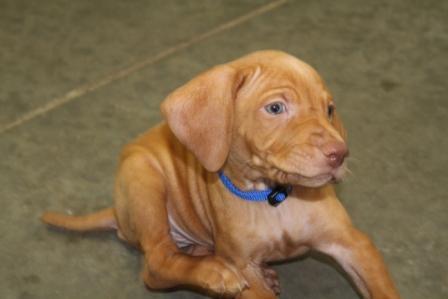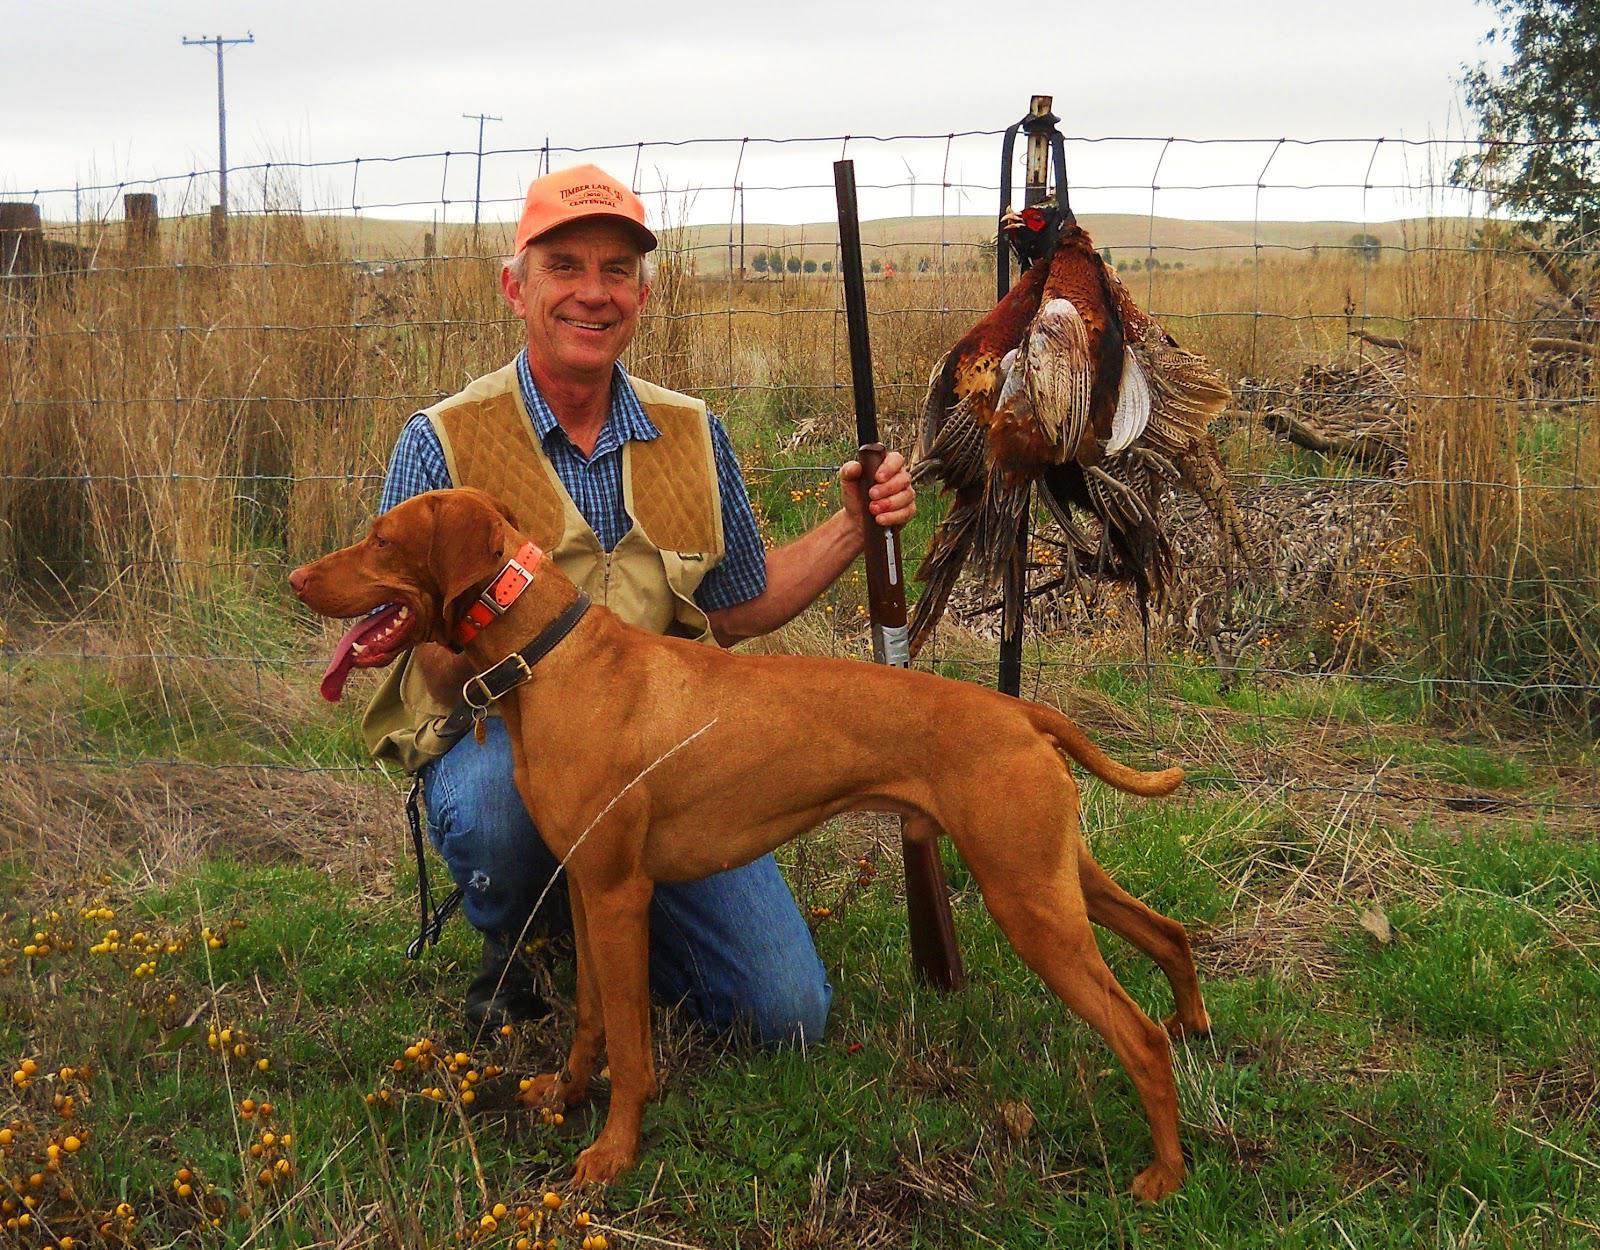The first image is the image on the left, the second image is the image on the right. For the images shown, is this caption "A dog has at least one front paw off the ground." true? Answer yes or no. No. The first image is the image on the left, the second image is the image on the right. Evaluate the accuracy of this statement regarding the images: "The dog on the right is posed with a hunting weapon and a fowl, while the dog on the left has a very visible collar.". Is it true? Answer yes or no. Yes. 